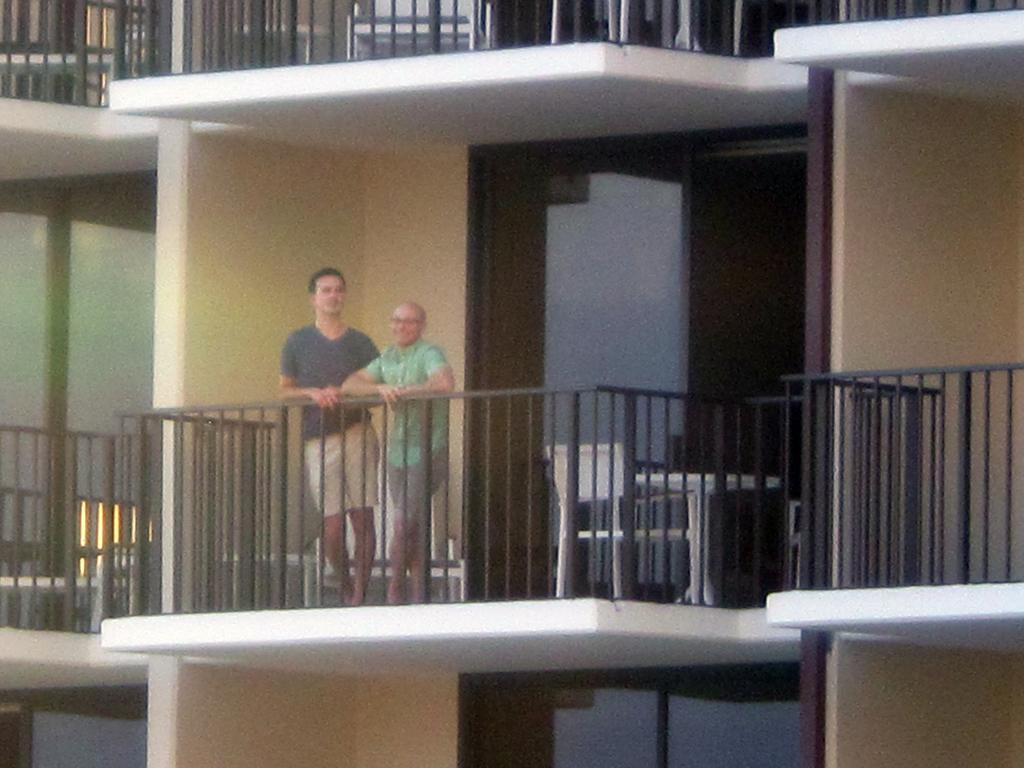What structure is visible in the image? There is a building in the image. Where are the two people located in the image? The two people are standing on a balcony. What feature does the balcony have? The balcony has a railing. What furniture is visible behind the people? There are chairs and a table behind the people. What type of oatmeal is being served on the table in the image? There is no oatmeal present in the image; it only shows a building, a balcony, and the people standing on it. 